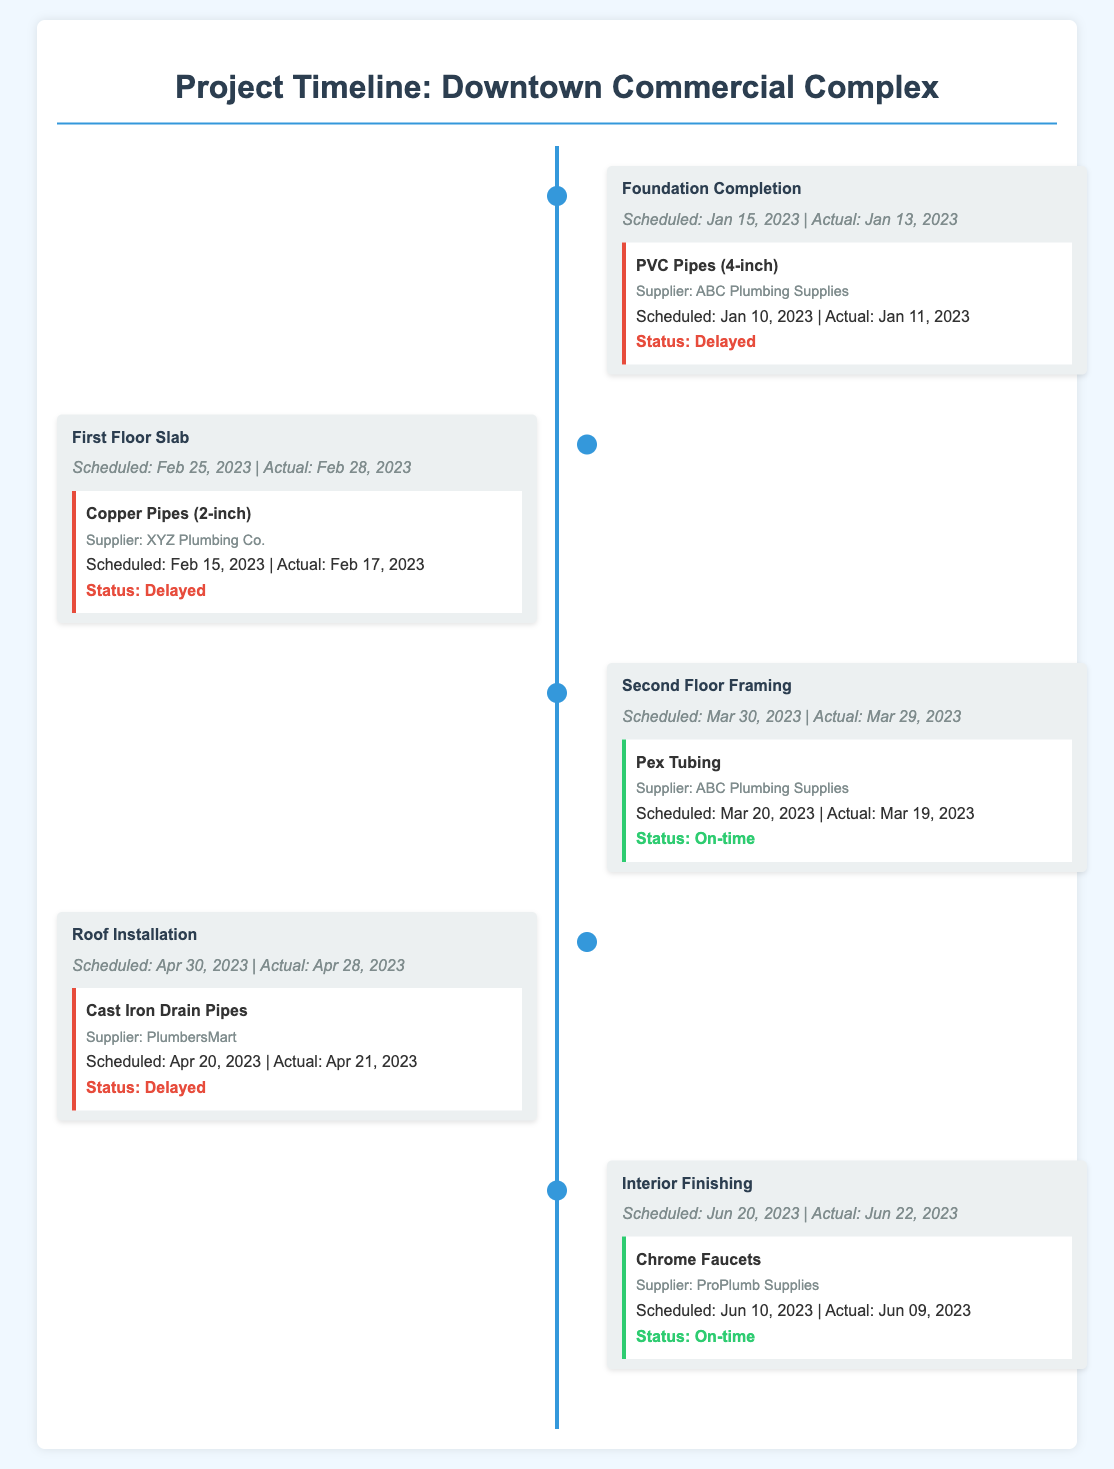What is the actual completion date for the foundation? The actual completion date for the foundation can be found in the timeline under the "Foundation Completion" milestone, which states the actual date.
Answer: January 13, 2023 Which plumbing material was delivered on time during the Second Floor Framing? The timeline shows the plumbing materials and their delivery statuses under each milestone, indicating which were on time.
Answer: Pex Tubing How many milestones were marked as delayed? The document provides the information on delivery statuses for each milestone, allowing us to count how many have delays.
Answer: 3 What is the scheduled date for the Interior Finishing? The scheduled date for Interior Finishing is specified in the timeline under that milestone.
Answer: June 20, 2023 What supplier was responsible for the Copper Pipes? The supplier for each plumbing material is mentioned in the timeline under the corresponding milestone.
Answer: XYZ Plumbing Co Which milestone has the earliest actual date of completion? By reviewing the actual completion dates for each milestone, we can identify the earliest one.
Answer: Foundation Completion How many plumbing materials were delayed in total? The status of each plumbing material is noted, allowing us to total the delays.
Answer: 3 What was the scheduled delivery date for the Chrome Faucets? The scheduled delivery date can be found in the material details for the Interior Finishing milestone.
Answer: June 10, 2023 